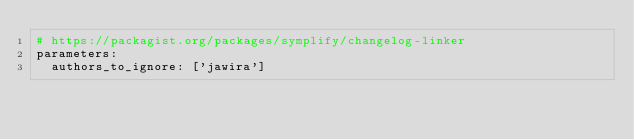<code> <loc_0><loc_0><loc_500><loc_500><_YAML_># https://packagist.org/packages/symplify/changelog-linker
parameters:
  authors_to_ignore: ['jawira']
</code> 